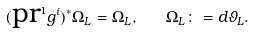Convert formula to latex. <formula><loc_0><loc_0><loc_500><loc_500>( \text {pr} ^ { 1 } g ^ { i } ) ^ { * } \Omega _ { L } = \Omega _ { L } , \quad \Omega _ { L } \colon = d \vartheta _ { L } .</formula> 